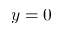<formula> <loc_0><loc_0><loc_500><loc_500>y = 0</formula> 